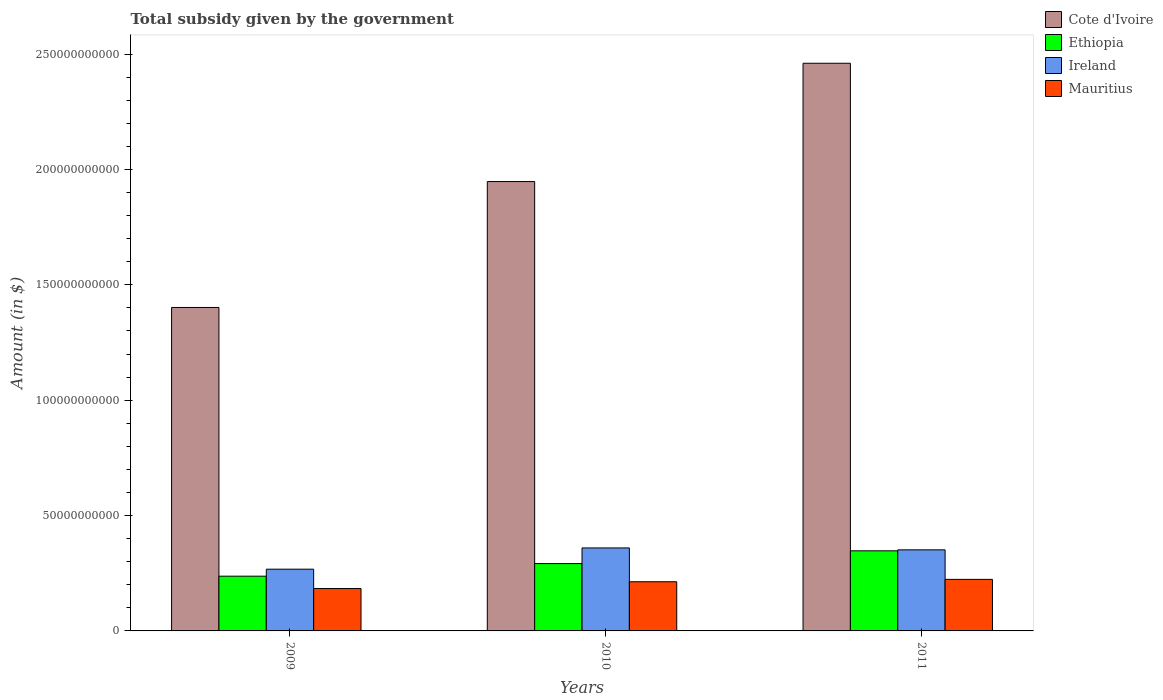How many groups of bars are there?
Your answer should be compact. 3. Are the number of bars per tick equal to the number of legend labels?
Give a very brief answer. Yes. Are the number of bars on each tick of the X-axis equal?
Offer a terse response. Yes. How many bars are there on the 3rd tick from the left?
Offer a terse response. 4. How many bars are there on the 2nd tick from the right?
Ensure brevity in your answer.  4. What is the total revenue collected by the government in Ethiopia in 2009?
Provide a short and direct response. 2.37e+1. Across all years, what is the maximum total revenue collected by the government in Cote d'Ivoire?
Ensure brevity in your answer.  2.46e+11. Across all years, what is the minimum total revenue collected by the government in Ethiopia?
Provide a short and direct response. 2.37e+1. In which year was the total revenue collected by the government in Mauritius maximum?
Offer a terse response. 2011. What is the total total revenue collected by the government in Ireland in the graph?
Make the answer very short. 9.79e+1. What is the difference between the total revenue collected by the government in Ethiopia in 2009 and that in 2010?
Provide a succinct answer. -5.47e+09. What is the difference between the total revenue collected by the government in Ethiopia in 2011 and the total revenue collected by the government in Ireland in 2010?
Offer a very short reply. -1.25e+09. What is the average total revenue collected by the government in Mauritius per year?
Keep it short and to the point. 2.07e+1. In the year 2010, what is the difference between the total revenue collected by the government in Ireland and total revenue collected by the government in Mauritius?
Your answer should be very brief. 1.47e+1. What is the ratio of the total revenue collected by the government in Cote d'Ivoire in 2009 to that in 2011?
Make the answer very short. 0.57. Is the difference between the total revenue collected by the government in Ireland in 2009 and 2010 greater than the difference between the total revenue collected by the government in Mauritius in 2009 and 2010?
Provide a succinct answer. No. What is the difference between the highest and the second highest total revenue collected by the government in Cote d'Ivoire?
Make the answer very short. 5.13e+1. What is the difference between the highest and the lowest total revenue collected by the government in Ireland?
Your answer should be very brief. 9.21e+09. Is it the case that in every year, the sum of the total revenue collected by the government in Ethiopia and total revenue collected by the government in Cote d'Ivoire is greater than the sum of total revenue collected by the government in Mauritius and total revenue collected by the government in Ireland?
Offer a terse response. Yes. What does the 2nd bar from the left in 2009 represents?
Your response must be concise. Ethiopia. What does the 3rd bar from the right in 2010 represents?
Offer a very short reply. Ethiopia. Are all the bars in the graph horizontal?
Provide a short and direct response. No. How many years are there in the graph?
Provide a succinct answer. 3. What is the difference between two consecutive major ticks on the Y-axis?
Offer a very short reply. 5.00e+1. Are the values on the major ticks of Y-axis written in scientific E-notation?
Give a very brief answer. No. Does the graph contain any zero values?
Keep it short and to the point. No. How many legend labels are there?
Ensure brevity in your answer.  4. What is the title of the graph?
Make the answer very short. Total subsidy given by the government. What is the label or title of the X-axis?
Give a very brief answer. Years. What is the label or title of the Y-axis?
Give a very brief answer. Amount (in $). What is the Amount (in $) in Cote d'Ivoire in 2009?
Give a very brief answer. 1.40e+11. What is the Amount (in $) of Ethiopia in 2009?
Provide a succinct answer. 2.37e+1. What is the Amount (in $) of Ireland in 2009?
Provide a short and direct response. 2.68e+1. What is the Amount (in $) in Mauritius in 2009?
Give a very brief answer. 1.84e+1. What is the Amount (in $) in Cote d'Ivoire in 2010?
Make the answer very short. 1.95e+11. What is the Amount (in $) of Ethiopia in 2010?
Offer a very short reply. 2.92e+1. What is the Amount (in $) in Ireland in 2010?
Offer a terse response. 3.60e+1. What is the Amount (in $) of Mauritius in 2010?
Ensure brevity in your answer.  2.13e+1. What is the Amount (in $) in Cote d'Ivoire in 2011?
Make the answer very short. 2.46e+11. What is the Amount (in $) of Ethiopia in 2011?
Offer a very short reply. 3.47e+1. What is the Amount (in $) in Ireland in 2011?
Offer a very short reply. 3.51e+1. What is the Amount (in $) of Mauritius in 2011?
Make the answer very short. 2.23e+1. Across all years, what is the maximum Amount (in $) in Cote d'Ivoire?
Your answer should be compact. 2.46e+11. Across all years, what is the maximum Amount (in $) of Ethiopia?
Keep it short and to the point. 3.47e+1. Across all years, what is the maximum Amount (in $) of Ireland?
Your answer should be compact. 3.60e+1. Across all years, what is the maximum Amount (in $) of Mauritius?
Ensure brevity in your answer.  2.23e+1. Across all years, what is the minimum Amount (in $) of Cote d'Ivoire?
Make the answer very short. 1.40e+11. Across all years, what is the minimum Amount (in $) of Ethiopia?
Provide a succinct answer. 2.37e+1. Across all years, what is the minimum Amount (in $) of Ireland?
Your answer should be very brief. 2.68e+1. Across all years, what is the minimum Amount (in $) in Mauritius?
Provide a succinct answer. 1.84e+1. What is the total Amount (in $) of Cote d'Ivoire in the graph?
Offer a terse response. 5.81e+11. What is the total Amount (in $) of Ethiopia in the graph?
Provide a short and direct response. 8.76e+1. What is the total Amount (in $) of Ireland in the graph?
Your response must be concise. 9.79e+1. What is the total Amount (in $) of Mauritius in the graph?
Ensure brevity in your answer.  6.20e+1. What is the difference between the Amount (in $) in Cote d'Ivoire in 2009 and that in 2010?
Give a very brief answer. -5.46e+1. What is the difference between the Amount (in $) of Ethiopia in 2009 and that in 2010?
Offer a terse response. -5.47e+09. What is the difference between the Amount (in $) of Ireland in 2009 and that in 2010?
Keep it short and to the point. -9.21e+09. What is the difference between the Amount (in $) in Mauritius in 2009 and that in 2010?
Give a very brief answer. -2.94e+09. What is the difference between the Amount (in $) in Cote d'Ivoire in 2009 and that in 2011?
Offer a very short reply. -1.06e+11. What is the difference between the Amount (in $) of Ethiopia in 2009 and that in 2011?
Your response must be concise. -1.10e+1. What is the difference between the Amount (in $) of Ireland in 2009 and that in 2011?
Offer a terse response. -8.38e+09. What is the difference between the Amount (in $) in Mauritius in 2009 and that in 2011?
Offer a very short reply. -3.97e+09. What is the difference between the Amount (in $) of Cote d'Ivoire in 2010 and that in 2011?
Make the answer very short. -5.13e+1. What is the difference between the Amount (in $) in Ethiopia in 2010 and that in 2011?
Provide a succinct answer. -5.52e+09. What is the difference between the Amount (in $) of Ireland in 2010 and that in 2011?
Ensure brevity in your answer.  8.34e+08. What is the difference between the Amount (in $) in Mauritius in 2010 and that in 2011?
Keep it short and to the point. -1.03e+09. What is the difference between the Amount (in $) of Cote d'Ivoire in 2009 and the Amount (in $) of Ethiopia in 2010?
Ensure brevity in your answer.  1.11e+11. What is the difference between the Amount (in $) in Cote d'Ivoire in 2009 and the Amount (in $) in Ireland in 2010?
Ensure brevity in your answer.  1.04e+11. What is the difference between the Amount (in $) in Cote d'Ivoire in 2009 and the Amount (in $) in Mauritius in 2010?
Your response must be concise. 1.19e+11. What is the difference between the Amount (in $) in Ethiopia in 2009 and the Amount (in $) in Ireland in 2010?
Ensure brevity in your answer.  -1.22e+1. What is the difference between the Amount (in $) in Ethiopia in 2009 and the Amount (in $) in Mauritius in 2010?
Your answer should be compact. 2.42e+09. What is the difference between the Amount (in $) of Ireland in 2009 and the Amount (in $) of Mauritius in 2010?
Your response must be concise. 5.45e+09. What is the difference between the Amount (in $) in Cote d'Ivoire in 2009 and the Amount (in $) in Ethiopia in 2011?
Keep it short and to the point. 1.05e+11. What is the difference between the Amount (in $) of Cote d'Ivoire in 2009 and the Amount (in $) of Ireland in 2011?
Give a very brief answer. 1.05e+11. What is the difference between the Amount (in $) of Cote d'Ivoire in 2009 and the Amount (in $) of Mauritius in 2011?
Give a very brief answer. 1.18e+11. What is the difference between the Amount (in $) of Ethiopia in 2009 and the Amount (in $) of Ireland in 2011?
Your answer should be compact. -1.14e+1. What is the difference between the Amount (in $) in Ethiopia in 2009 and the Amount (in $) in Mauritius in 2011?
Provide a short and direct response. 1.38e+09. What is the difference between the Amount (in $) in Ireland in 2009 and the Amount (in $) in Mauritius in 2011?
Offer a terse response. 4.42e+09. What is the difference between the Amount (in $) of Cote d'Ivoire in 2010 and the Amount (in $) of Ethiopia in 2011?
Your answer should be compact. 1.60e+11. What is the difference between the Amount (in $) of Cote d'Ivoire in 2010 and the Amount (in $) of Ireland in 2011?
Your answer should be compact. 1.60e+11. What is the difference between the Amount (in $) in Cote d'Ivoire in 2010 and the Amount (in $) in Mauritius in 2011?
Your answer should be very brief. 1.72e+11. What is the difference between the Amount (in $) of Ethiopia in 2010 and the Amount (in $) of Ireland in 2011?
Keep it short and to the point. -5.95e+09. What is the difference between the Amount (in $) of Ethiopia in 2010 and the Amount (in $) of Mauritius in 2011?
Offer a terse response. 6.85e+09. What is the difference between the Amount (in $) of Ireland in 2010 and the Amount (in $) of Mauritius in 2011?
Your answer should be very brief. 1.36e+1. What is the average Amount (in $) of Cote d'Ivoire per year?
Your answer should be very brief. 1.94e+11. What is the average Amount (in $) in Ethiopia per year?
Ensure brevity in your answer.  2.92e+1. What is the average Amount (in $) of Ireland per year?
Provide a short and direct response. 3.26e+1. What is the average Amount (in $) of Mauritius per year?
Provide a short and direct response. 2.07e+1. In the year 2009, what is the difference between the Amount (in $) in Cote d'Ivoire and Amount (in $) in Ethiopia?
Offer a very short reply. 1.16e+11. In the year 2009, what is the difference between the Amount (in $) of Cote d'Ivoire and Amount (in $) of Ireland?
Keep it short and to the point. 1.13e+11. In the year 2009, what is the difference between the Amount (in $) in Cote d'Ivoire and Amount (in $) in Mauritius?
Ensure brevity in your answer.  1.22e+11. In the year 2009, what is the difference between the Amount (in $) of Ethiopia and Amount (in $) of Ireland?
Your answer should be very brief. -3.03e+09. In the year 2009, what is the difference between the Amount (in $) of Ethiopia and Amount (in $) of Mauritius?
Provide a succinct answer. 5.36e+09. In the year 2009, what is the difference between the Amount (in $) of Ireland and Amount (in $) of Mauritius?
Offer a terse response. 8.39e+09. In the year 2010, what is the difference between the Amount (in $) of Cote d'Ivoire and Amount (in $) of Ethiopia?
Provide a short and direct response. 1.66e+11. In the year 2010, what is the difference between the Amount (in $) in Cote d'Ivoire and Amount (in $) in Ireland?
Give a very brief answer. 1.59e+11. In the year 2010, what is the difference between the Amount (in $) of Cote d'Ivoire and Amount (in $) of Mauritius?
Provide a succinct answer. 1.73e+11. In the year 2010, what is the difference between the Amount (in $) of Ethiopia and Amount (in $) of Ireland?
Make the answer very short. -6.78e+09. In the year 2010, what is the difference between the Amount (in $) of Ethiopia and Amount (in $) of Mauritius?
Ensure brevity in your answer.  7.88e+09. In the year 2010, what is the difference between the Amount (in $) in Ireland and Amount (in $) in Mauritius?
Offer a terse response. 1.47e+1. In the year 2011, what is the difference between the Amount (in $) in Cote d'Ivoire and Amount (in $) in Ethiopia?
Your response must be concise. 2.11e+11. In the year 2011, what is the difference between the Amount (in $) in Cote d'Ivoire and Amount (in $) in Ireland?
Give a very brief answer. 2.11e+11. In the year 2011, what is the difference between the Amount (in $) in Cote d'Ivoire and Amount (in $) in Mauritius?
Ensure brevity in your answer.  2.24e+11. In the year 2011, what is the difference between the Amount (in $) in Ethiopia and Amount (in $) in Ireland?
Provide a succinct answer. -4.20e+08. In the year 2011, what is the difference between the Amount (in $) in Ethiopia and Amount (in $) in Mauritius?
Give a very brief answer. 1.24e+1. In the year 2011, what is the difference between the Amount (in $) of Ireland and Amount (in $) of Mauritius?
Ensure brevity in your answer.  1.28e+1. What is the ratio of the Amount (in $) in Cote d'Ivoire in 2009 to that in 2010?
Make the answer very short. 0.72. What is the ratio of the Amount (in $) of Ethiopia in 2009 to that in 2010?
Provide a succinct answer. 0.81. What is the ratio of the Amount (in $) in Ireland in 2009 to that in 2010?
Your answer should be compact. 0.74. What is the ratio of the Amount (in $) in Mauritius in 2009 to that in 2010?
Make the answer very short. 0.86. What is the ratio of the Amount (in $) in Cote d'Ivoire in 2009 to that in 2011?
Make the answer very short. 0.57. What is the ratio of the Amount (in $) of Ethiopia in 2009 to that in 2011?
Your answer should be very brief. 0.68. What is the ratio of the Amount (in $) of Ireland in 2009 to that in 2011?
Give a very brief answer. 0.76. What is the ratio of the Amount (in $) of Mauritius in 2009 to that in 2011?
Your answer should be compact. 0.82. What is the ratio of the Amount (in $) in Cote d'Ivoire in 2010 to that in 2011?
Provide a short and direct response. 0.79. What is the ratio of the Amount (in $) of Ethiopia in 2010 to that in 2011?
Offer a very short reply. 0.84. What is the ratio of the Amount (in $) of Ireland in 2010 to that in 2011?
Keep it short and to the point. 1.02. What is the ratio of the Amount (in $) in Mauritius in 2010 to that in 2011?
Offer a very short reply. 0.95. What is the difference between the highest and the second highest Amount (in $) of Cote d'Ivoire?
Keep it short and to the point. 5.13e+1. What is the difference between the highest and the second highest Amount (in $) of Ethiopia?
Your response must be concise. 5.52e+09. What is the difference between the highest and the second highest Amount (in $) in Ireland?
Provide a succinct answer. 8.34e+08. What is the difference between the highest and the second highest Amount (in $) in Mauritius?
Your answer should be very brief. 1.03e+09. What is the difference between the highest and the lowest Amount (in $) of Cote d'Ivoire?
Your answer should be very brief. 1.06e+11. What is the difference between the highest and the lowest Amount (in $) of Ethiopia?
Give a very brief answer. 1.10e+1. What is the difference between the highest and the lowest Amount (in $) in Ireland?
Offer a very short reply. 9.21e+09. What is the difference between the highest and the lowest Amount (in $) of Mauritius?
Make the answer very short. 3.97e+09. 